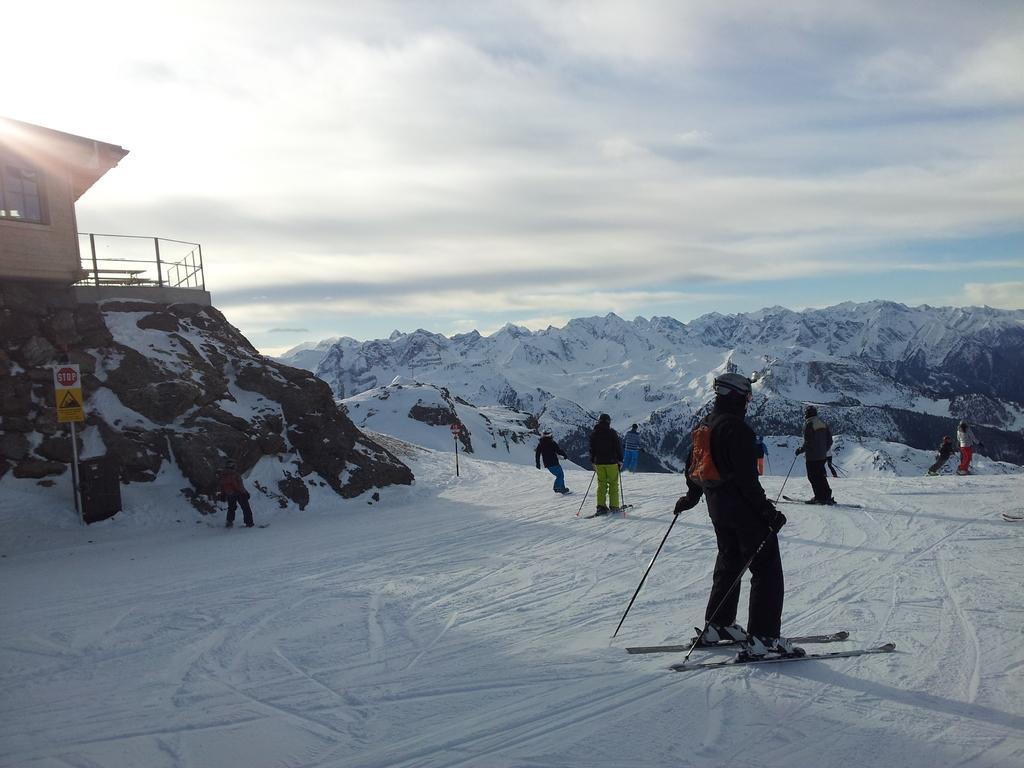How would you summarize this image in a sentence or two? Sky is cloudy. Land is covered with snow. Here we can see a signboard and house with windows. These people are standing on snow with skis and holding sticks. Background there are mountains with snow. 